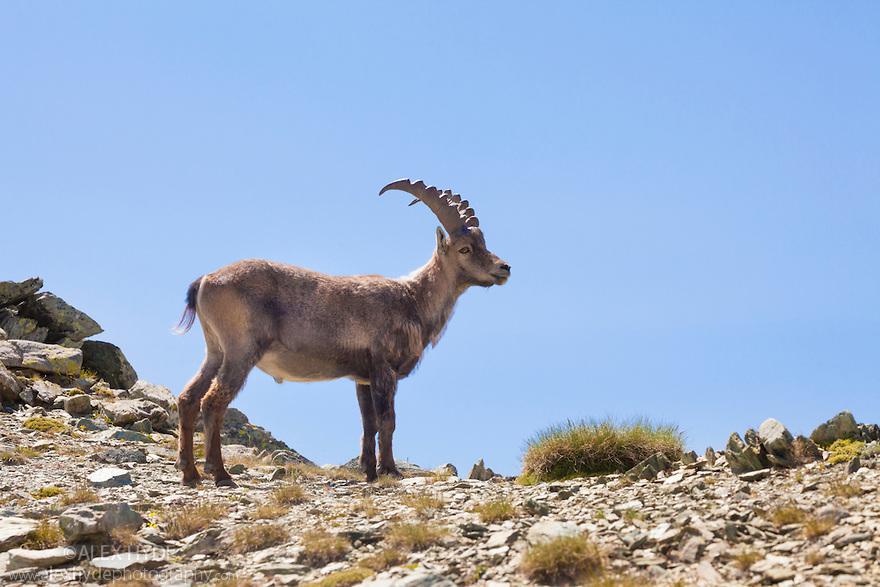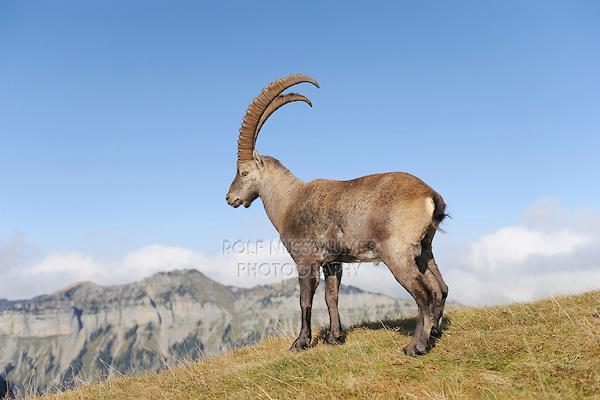The first image is the image on the left, the second image is the image on the right. Assess this claim about the two images: "Each image shows a long-horned animal standing on a rocky peak, and each animal is looking in the same general direction.". Correct or not? Answer yes or no. No. The first image is the image on the left, the second image is the image on the right. For the images shown, is this caption "Both rams are standing on rocky ground." true? Answer yes or no. No. 